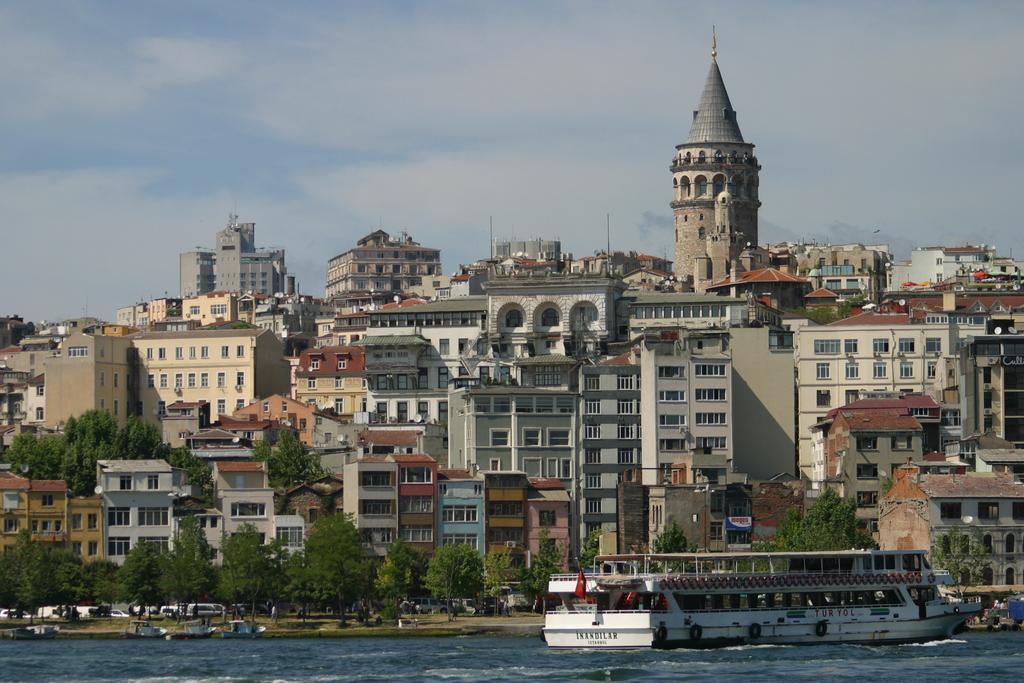What is at the bottom of the image? There is water at the bottom of the image. What can be seen on the right side of the image? There is a boat on the right side of the image. What is located in the middle of the image? There are trees and buildings in the middle of the image. What is visible at the top of the image? The sky is visible at the top of the image. What story does the son tell about the company in the image? There is no story, son, or company present in the image. The image features water, a boat, trees, buildings, and the sky. 